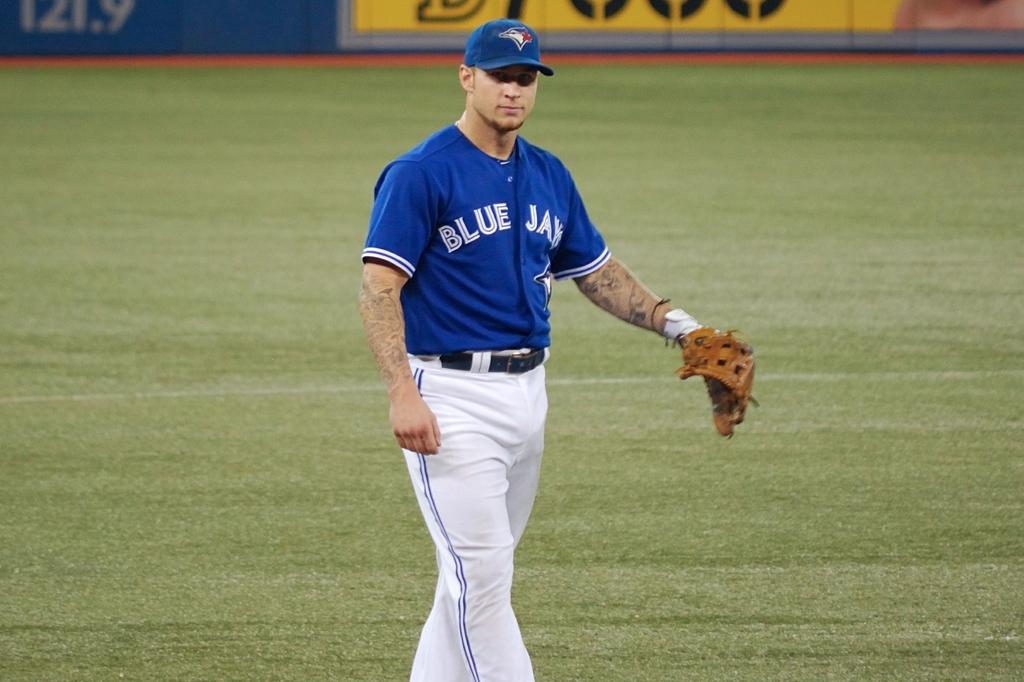What is the team name on the front of the jersey?
Ensure brevity in your answer.  Blue jays. 